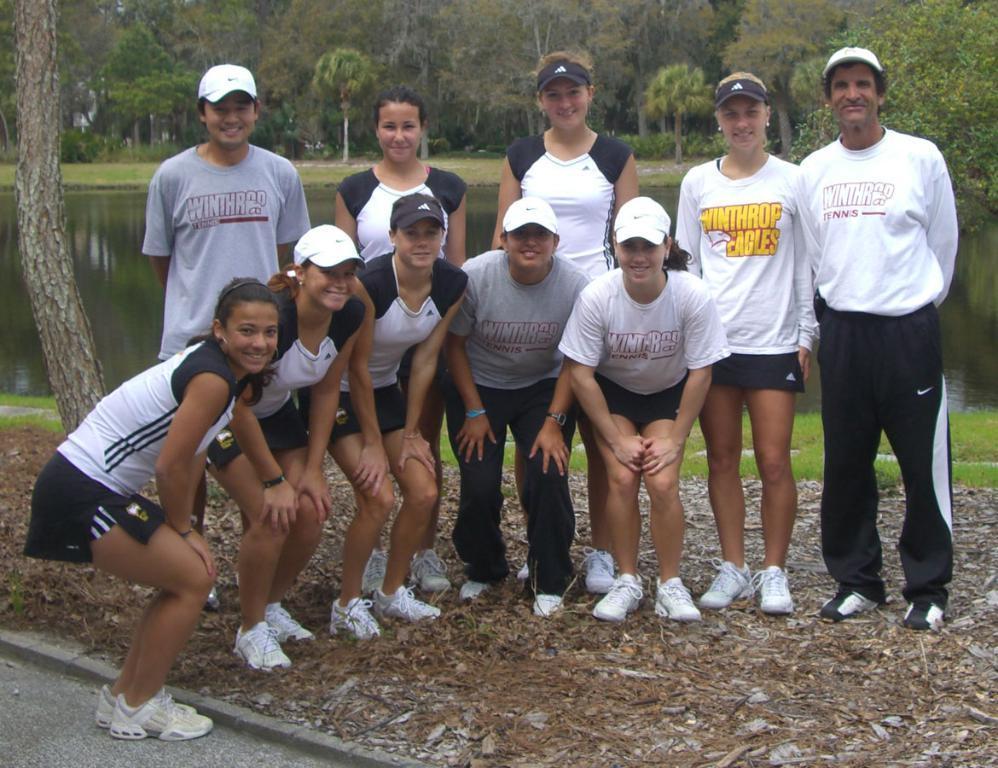Please provide a concise description of this image. In this picture I can see group of people standing and smiling, there is grass, there is water, and in the background there are trees. 